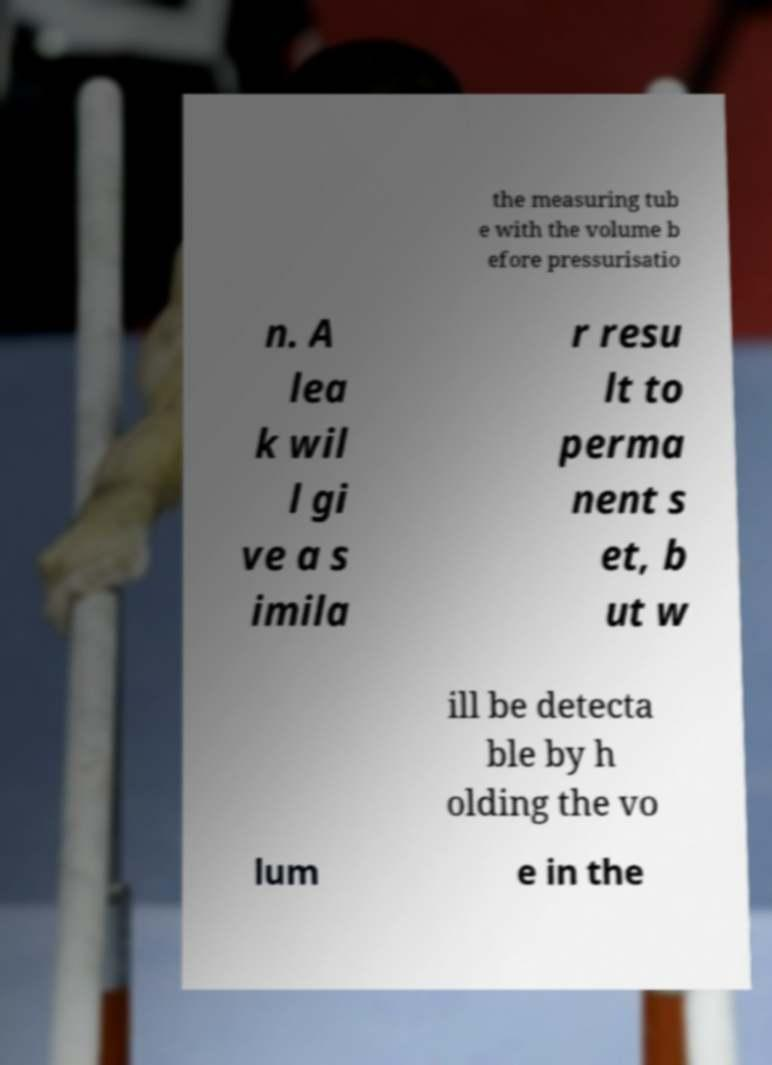Could you extract and type out the text from this image? the measuring tub e with the volume b efore pressurisatio n. A lea k wil l gi ve a s imila r resu lt to perma nent s et, b ut w ill be detecta ble by h olding the vo lum e in the 